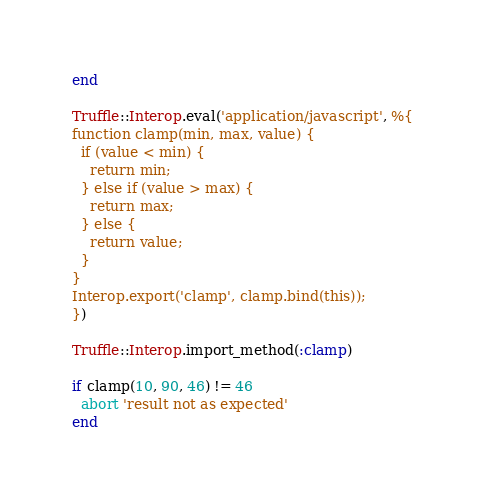Convert code to text. <code><loc_0><loc_0><loc_500><loc_500><_Ruby_>end

Truffle::Interop.eval('application/javascript', %{
function clamp(min, max, value) {
  if (value < min) {
    return min;
  } else if (value > max) {
    return max;
  } else {
    return value;
  }
}
Interop.export('clamp', clamp.bind(this));
})

Truffle::Interop.import_method(:clamp)

if clamp(10, 90, 46) != 46
  abort 'result not as expected'
end
</code> 